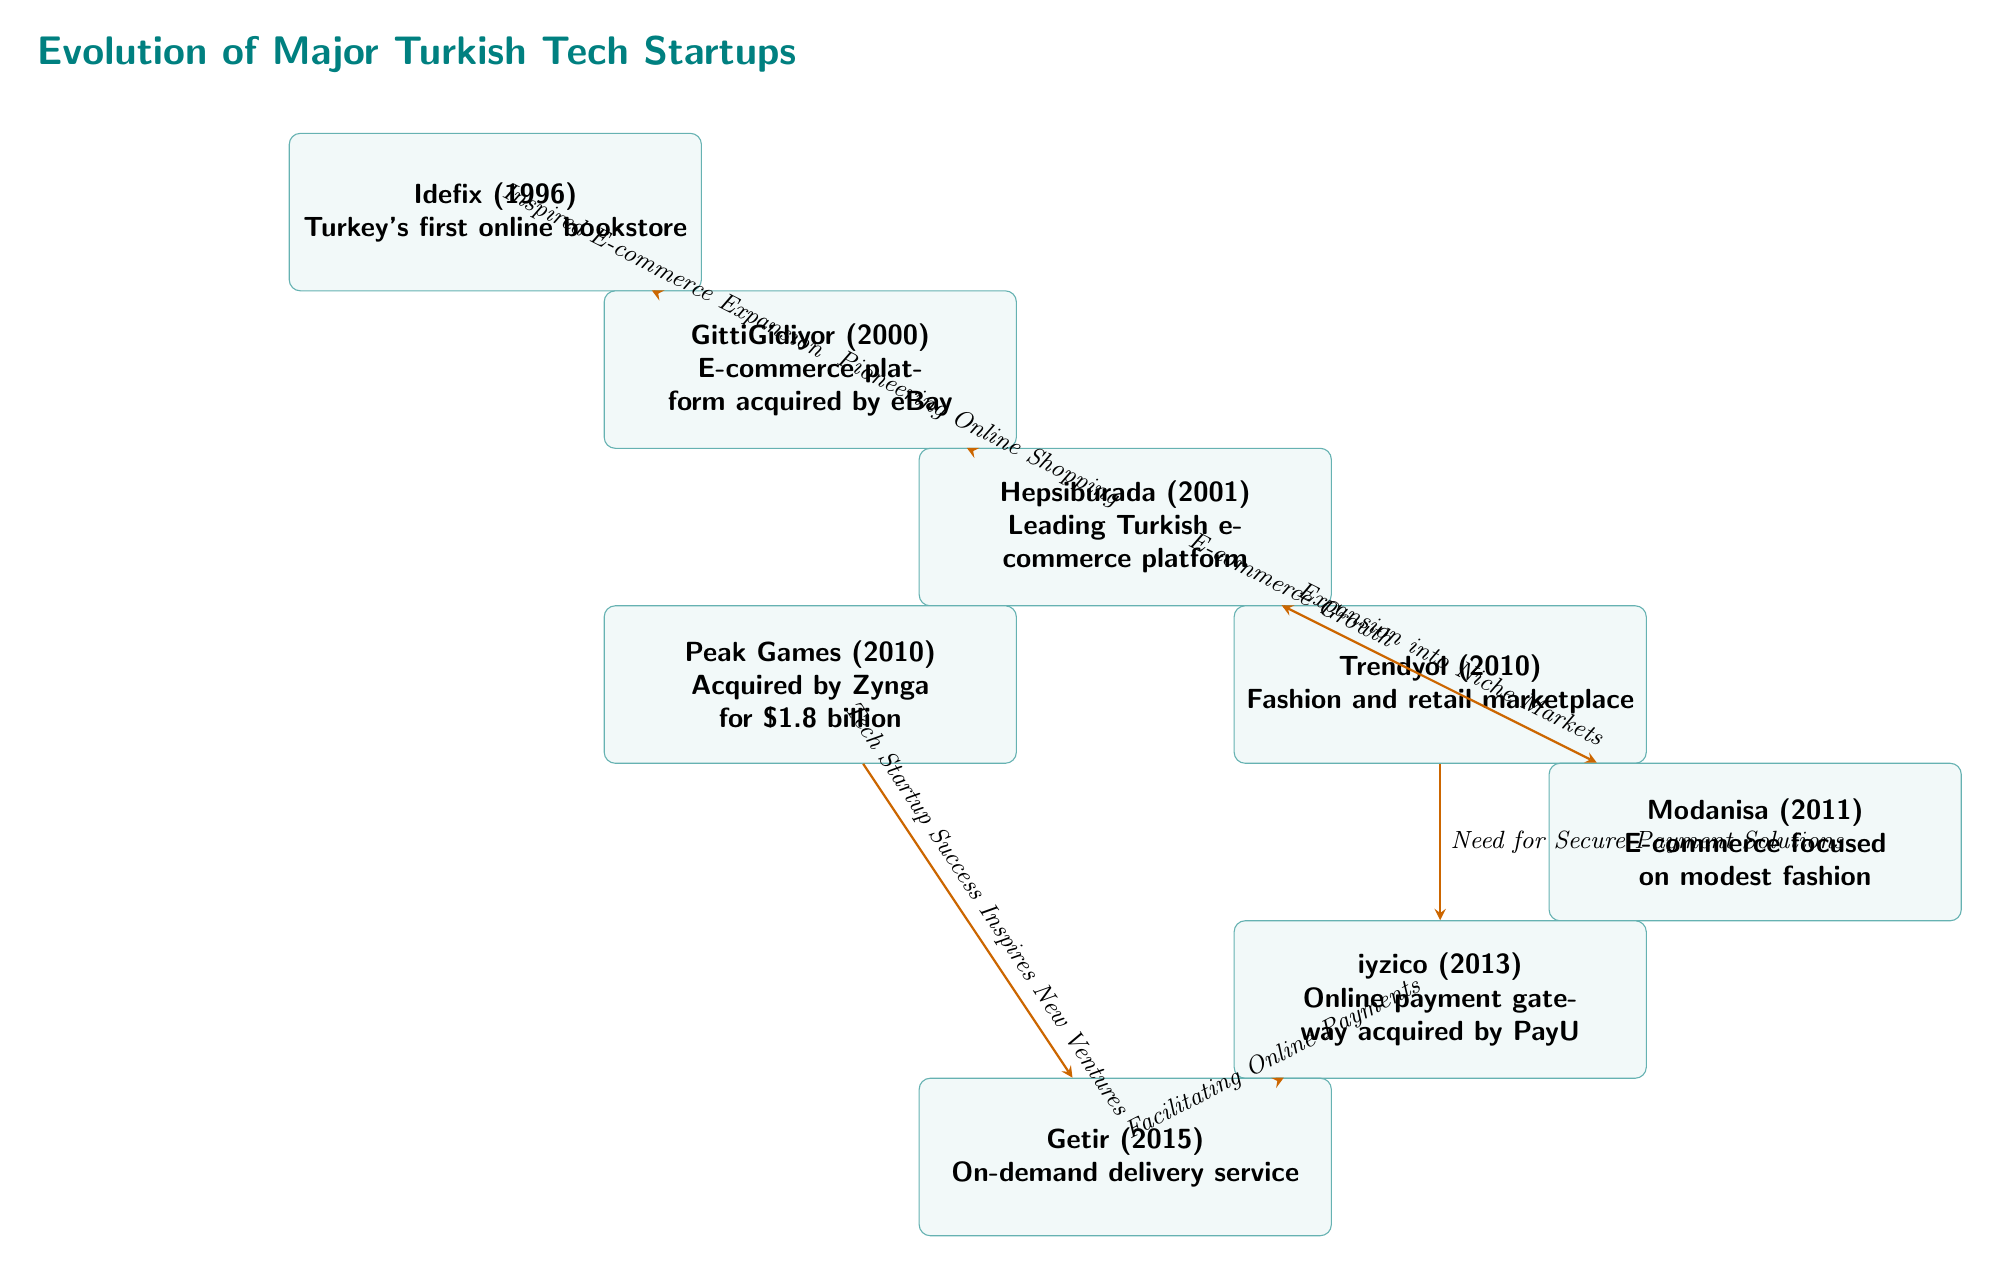What is the first major technology startup listed in the diagram? The first major startup shown at the top of the diagram is "Idefix," which was founded in 1996 as Turkey's first online bookstore.
Answer: Idefix How many technology startups are mentioned in the diagram? There are a total of 7 technology startups mentioned in the diagram, starting from Idefix and ending at Getir.
Answer: 7 Which startup was acquired by eBay? In the diagram, "GittiGidiyor," founded in 2000, is noted as the e-commerce platform acquired by eBay.
Answer: GittiGidiyor What does the arrow from "Hepsiburada" to "Trendyol" signify? The arrow indicates that "Hepsiburada" is connected to "Trendyol" with the reasoning of "E-commerce Growth," showing a relationship of influence or inspiration during the expansion of e-commerce.
Answer: E-commerce Growth What originated as a response to the need for secure payment solutions? The startup identified in the diagram as addressing the need for secure payment solutions is "iyzico," which was founded in 2013.
Answer: iyzico What is the relationship indicated by the arrow from "Peak Games" to "Getir"? The connection signifies that "Tech Startup Success Inspires New Ventures," implying that the success of Peak Games motivated the creation of other tech startups like Getir.
Answer: Tech Startup Success Inspires New Ventures Which startup focuses on modest fashion? According to the diagram, "Modanisa," founded in 2011, is the startup that focuses specifically on modest fashion within e-commerce.
Answer: Modanisa What year was "Trendyol" established? The diagram states that "Trendyol" was established in the year 2010, as seen in the node details.
Answer: 2010 